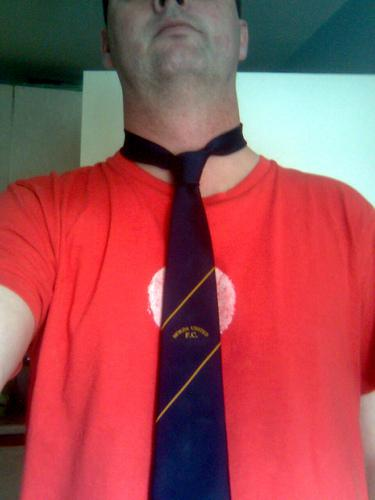Question: how many stripes are on the tie?
Choices:
A. Two.
B. Three.
C. Four.
D. Five.
Answer with the letter. Answer: A Question: where is the man?
Choices:
A. In the yard.
B. In the garage.
C. In the swimming pool.
D. In a room.
Answer with the letter. Answer: D 